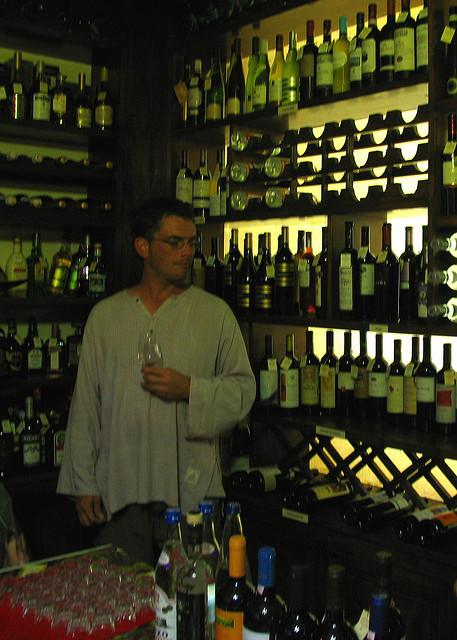Where is the man? winery 